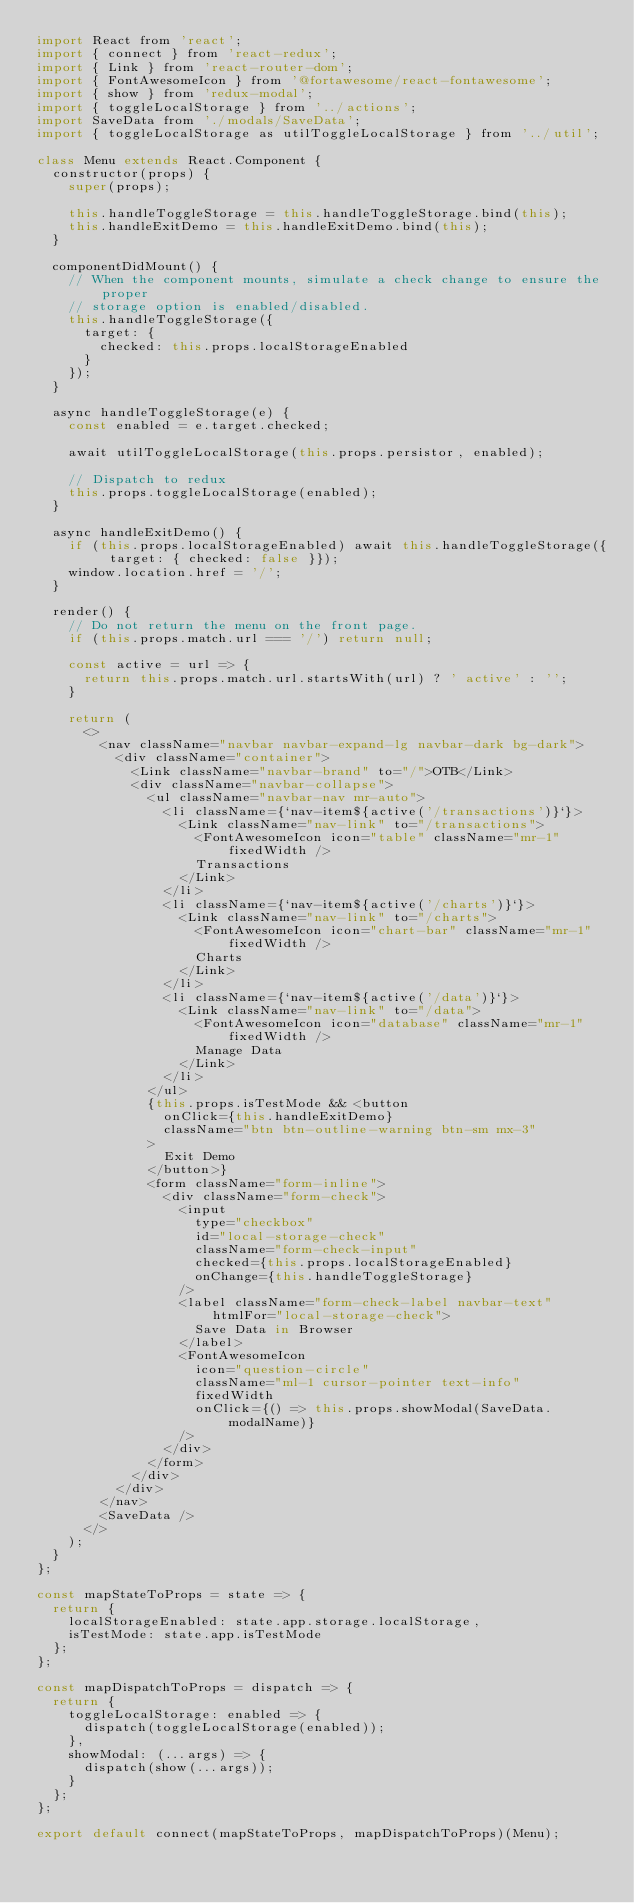<code> <loc_0><loc_0><loc_500><loc_500><_JavaScript_>import React from 'react';
import { connect } from 'react-redux';
import { Link } from 'react-router-dom';
import { FontAwesomeIcon } from '@fortawesome/react-fontawesome';
import { show } from 'redux-modal';
import { toggleLocalStorage } from '../actions';
import SaveData from './modals/SaveData';
import { toggleLocalStorage as utilToggleLocalStorage } from '../util';

class Menu extends React.Component {
  constructor(props) {
    super(props);

    this.handleToggleStorage = this.handleToggleStorage.bind(this);
    this.handleExitDemo = this.handleExitDemo.bind(this);
  }

  componentDidMount() {
    // When the component mounts, simulate a check change to ensure the proper
    // storage option is enabled/disabled.
    this.handleToggleStorage({
      target: {
        checked: this.props.localStorageEnabled
      }
    });
  }

  async handleToggleStorage(e) {
    const enabled = e.target.checked;

    await utilToggleLocalStorage(this.props.persistor, enabled);

    // Dispatch to redux
    this.props.toggleLocalStorage(enabled);
  }

  async handleExitDemo() {
    if (this.props.localStorageEnabled) await this.handleToggleStorage({ target: { checked: false }});
    window.location.href = '/';
  }

  render() {
    // Do not return the menu on the front page.
    if (this.props.match.url === '/') return null;

    const active = url => {
      return this.props.match.url.startsWith(url) ? ' active' : '';
    }

    return (
      <>
        <nav className="navbar navbar-expand-lg navbar-dark bg-dark">
          <div className="container">
            <Link className="navbar-brand" to="/">OTB</Link>
            <div className="navbar-collapse">
              <ul className="navbar-nav mr-auto">
                <li className={`nav-item${active('/transactions')}`}>
                  <Link className="nav-link" to="/transactions">
                    <FontAwesomeIcon icon="table" className="mr-1" fixedWidth />
                    Transactions
                  </Link>
                </li>
                <li className={`nav-item${active('/charts')}`}>
                  <Link className="nav-link" to="/charts">
                    <FontAwesomeIcon icon="chart-bar" className="mr-1" fixedWidth />
                    Charts
                  </Link>
                </li>
                <li className={`nav-item${active('/data')}`}>
                  <Link className="nav-link" to="/data">
                    <FontAwesomeIcon icon="database" className="mr-1" fixedWidth />
                    Manage Data
                  </Link>
                </li>
              </ul>
              {this.props.isTestMode && <button
                onClick={this.handleExitDemo}
                className="btn btn-outline-warning btn-sm mx-3"
              >
                Exit Demo
              </button>}
              <form className="form-inline">
                <div className="form-check">
                  <input
                    type="checkbox"
                    id="local-storage-check"
                    className="form-check-input"
                    checked={this.props.localStorageEnabled}
                    onChange={this.handleToggleStorage}
                  />
                  <label className="form-check-label navbar-text" htmlFor="local-storage-check">
                    Save Data in Browser
                  </label>
                  <FontAwesomeIcon
                    icon="question-circle"
                    className="ml-1 cursor-pointer text-info"
                    fixedWidth
                    onClick={() => this.props.showModal(SaveData.modalName)}
                  />
                </div>
              </form>
            </div>
          </div>
        </nav>
        <SaveData />
      </>
    );
  }
};

const mapStateToProps = state => {
  return {
    localStorageEnabled: state.app.storage.localStorage,
    isTestMode: state.app.isTestMode
  };
};

const mapDispatchToProps = dispatch => {
  return {
    toggleLocalStorage: enabled => {
      dispatch(toggleLocalStorage(enabled));
    },
    showModal: (...args) => {
      dispatch(show(...args));
    }
  };
};

export default connect(mapStateToProps, mapDispatchToProps)(Menu);
</code> 